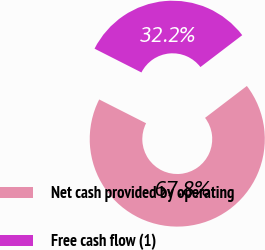<chart> <loc_0><loc_0><loc_500><loc_500><pie_chart><fcel>Net cash provided by operating<fcel>Free cash flow (1)<nl><fcel>67.84%<fcel>32.16%<nl></chart> 